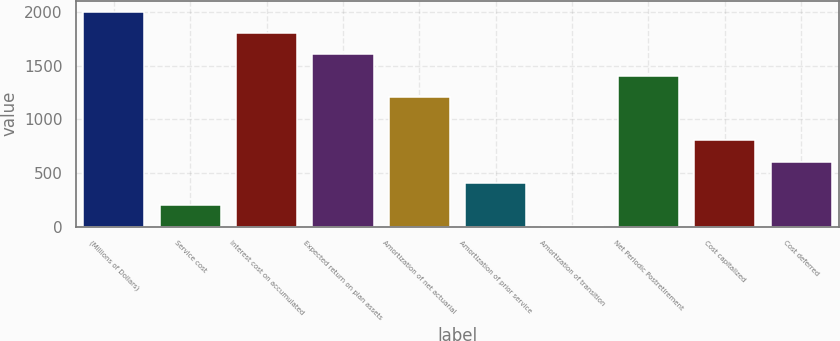Convert chart. <chart><loc_0><loc_0><loc_500><loc_500><bar_chart><fcel>(Millions of Dollars)<fcel>Service cost<fcel>Interest cost on accumulated<fcel>Expected return on plan assets<fcel>Amortization of net actuarial<fcel>Amortization of prior service<fcel>Amortization of transition<fcel>Net Periodic Postretirement<fcel>Cost capitalized<fcel>Cost deferred<nl><fcel>2005<fcel>204.1<fcel>1804.9<fcel>1604.8<fcel>1204.6<fcel>404.2<fcel>4<fcel>1404.7<fcel>804.4<fcel>604.3<nl></chart> 